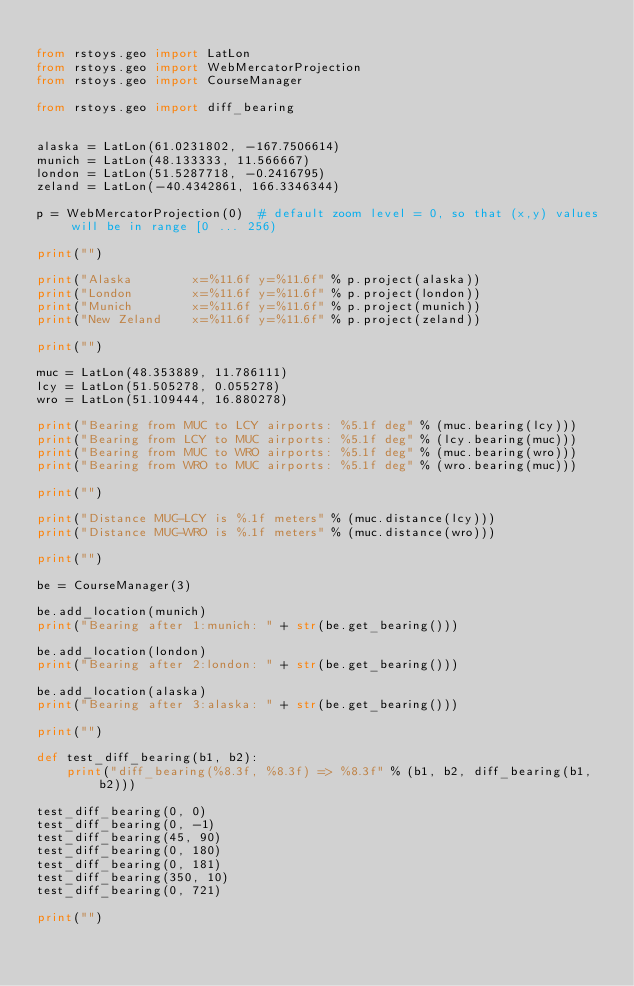Convert code to text. <code><loc_0><loc_0><loc_500><loc_500><_Python_>
from rstoys.geo import LatLon
from rstoys.geo import WebMercatorProjection
from rstoys.geo import CourseManager

from rstoys.geo import diff_bearing


alaska = LatLon(61.0231802, -167.7506614)
munich = LatLon(48.133333, 11.566667)
london = LatLon(51.5287718, -0.2416795)
zeland = LatLon(-40.4342861, 166.3346344)

p = WebMercatorProjection(0)  # default zoom level = 0, so that (x,y) values will be in range [0 ... 256)

print("")

print("Alaska        x=%11.6f y=%11.6f" % p.project(alaska))
print("London        x=%11.6f y=%11.6f" % p.project(london))
print("Munich        x=%11.6f y=%11.6f" % p.project(munich))
print("New Zeland    x=%11.6f y=%11.6f" % p.project(zeland))

print("")

muc = LatLon(48.353889, 11.786111)
lcy = LatLon(51.505278, 0.055278)
wro = LatLon(51.109444, 16.880278)

print("Bearing from MUC to LCY airports: %5.1f deg" % (muc.bearing(lcy)))
print("Bearing from LCY to MUC airports: %5.1f deg" % (lcy.bearing(muc)))
print("Bearing from MUC to WRO airports: %5.1f deg" % (muc.bearing(wro)))
print("Bearing from WRO to MUC airports: %5.1f deg" % (wro.bearing(muc)))

print("")

print("Distance MUC-LCY is %.1f meters" % (muc.distance(lcy)))
print("Distance MUC-WRO is %.1f meters" % (muc.distance(wro)))

print("")

be = CourseManager(3)

be.add_location(munich)
print("Bearing after 1:munich: " + str(be.get_bearing()))

be.add_location(london)
print("Bearing after 2:london: " + str(be.get_bearing()))

be.add_location(alaska)
print("Bearing after 3:alaska: " + str(be.get_bearing()))

print("")

def test_diff_bearing(b1, b2):
    print("diff_bearing(%8.3f, %8.3f) => %8.3f" % (b1, b2, diff_bearing(b1, b2)))

test_diff_bearing(0, 0)
test_diff_bearing(0, -1)
test_diff_bearing(45, 90)
test_diff_bearing(0, 180)
test_diff_bearing(0, 181)
test_diff_bearing(350, 10)
test_diff_bearing(0, 721)

print("")
</code> 